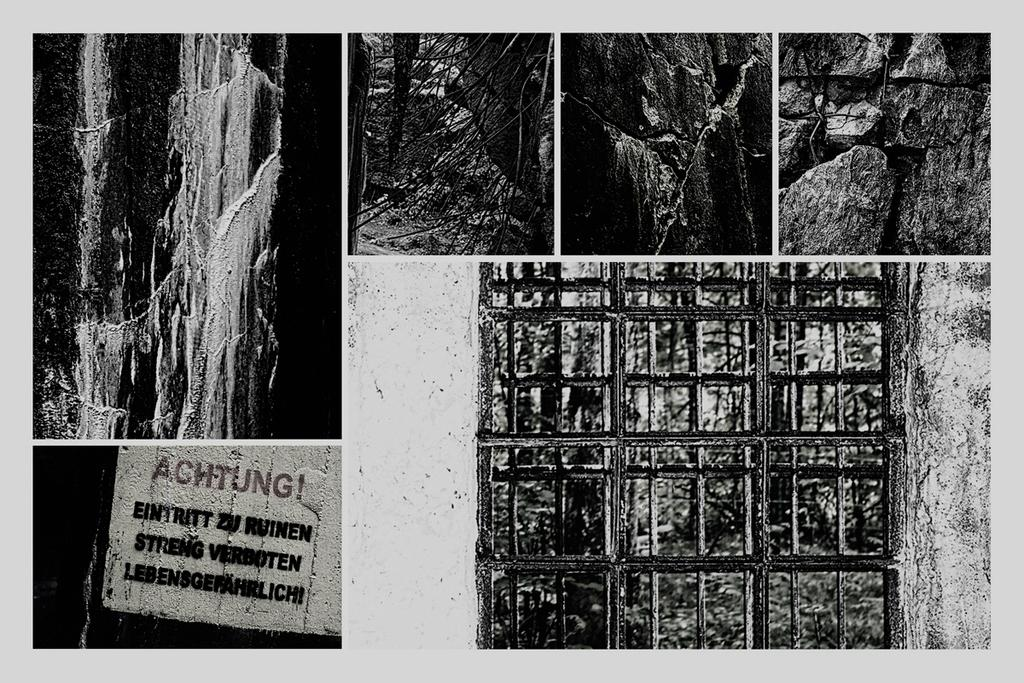What type of natural elements can be seen in the image? There are stones and trees in the image. What man-made object is present in the image? There is a board with writing in the image. What is the color scheme of the image? The image is in black and white. What type of objects can be seen in the image, considering the color scheme? There are objects in black and white color in the image. How many trains can be seen in the image? There are no trains present in the image. What type of plate is visible in the image? There is no plate visible in the image. 